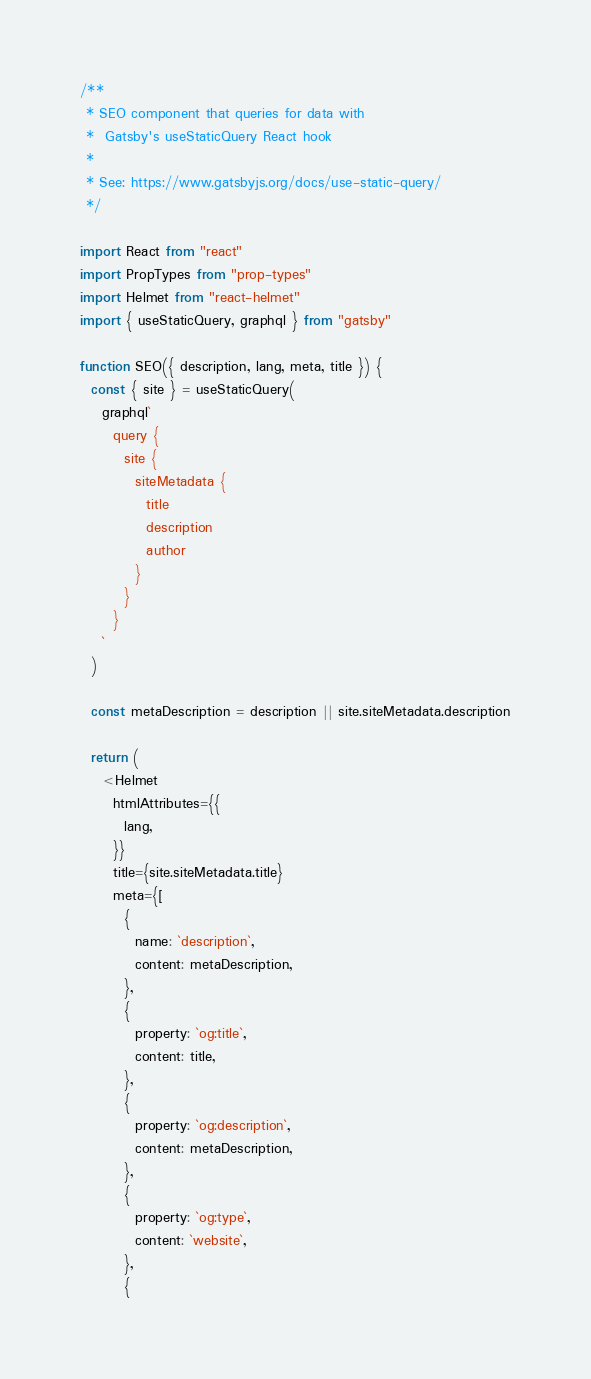<code> <loc_0><loc_0><loc_500><loc_500><_JavaScript_>/**
 * SEO component that queries for data with
 *  Gatsby's useStaticQuery React hook
 *
 * See: https://www.gatsbyjs.org/docs/use-static-query/
 */

import React from "react"
import PropTypes from "prop-types"
import Helmet from "react-helmet"
import { useStaticQuery, graphql } from "gatsby"

function SEO({ description, lang, meta, title }) {
  const { site } = useStaticQuery(
    graphql`
      query {
        site {
          siteMetadata {
            title
            description
            author
          }
        }
      }
    `
  )

  const metaDescription = description || site.siteMetadata.description

  return (
    <Helmet
      htmlAttributes={{
        lang,
      }}
      title={site.siteMetadata.title}
      meta={[
        {
          name: `description`,
          content: metaDescription,
        },
        {
          property: `og:title`,
          content: title,
        },
        {
          property: `og:description`,
          content: metaDescription,
        },
        {
          property: `og:type`,
          content: `website`,
        },
        {</code> 